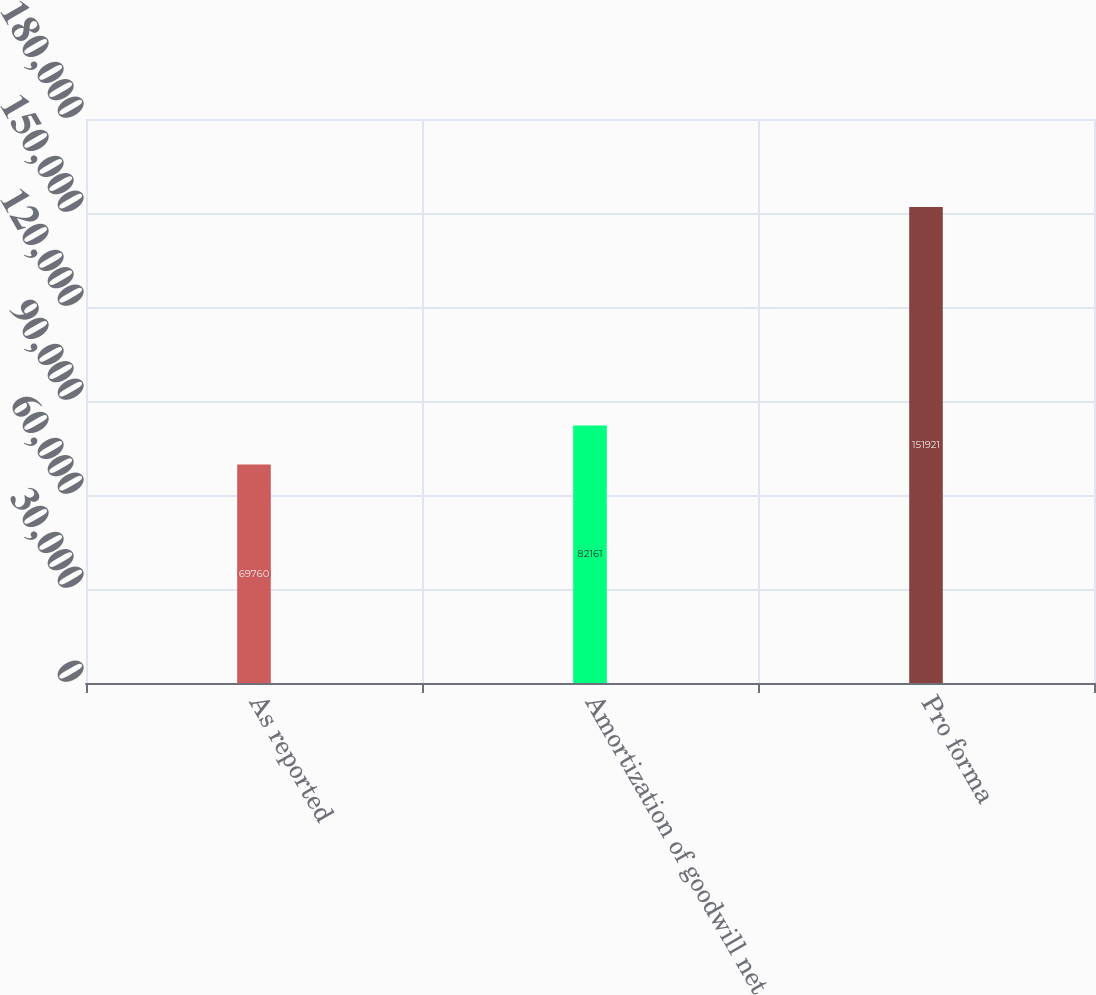Convert chart to OTSL. <chart><loc_0><loc_0><loc_500><loc_500><bar_chart><fcel>As reported<fcel>Amortization of goodwill net<fcel>Pro forma<nl><fcel>69760<fcel>82161<fcel>151921<nl></chart> 